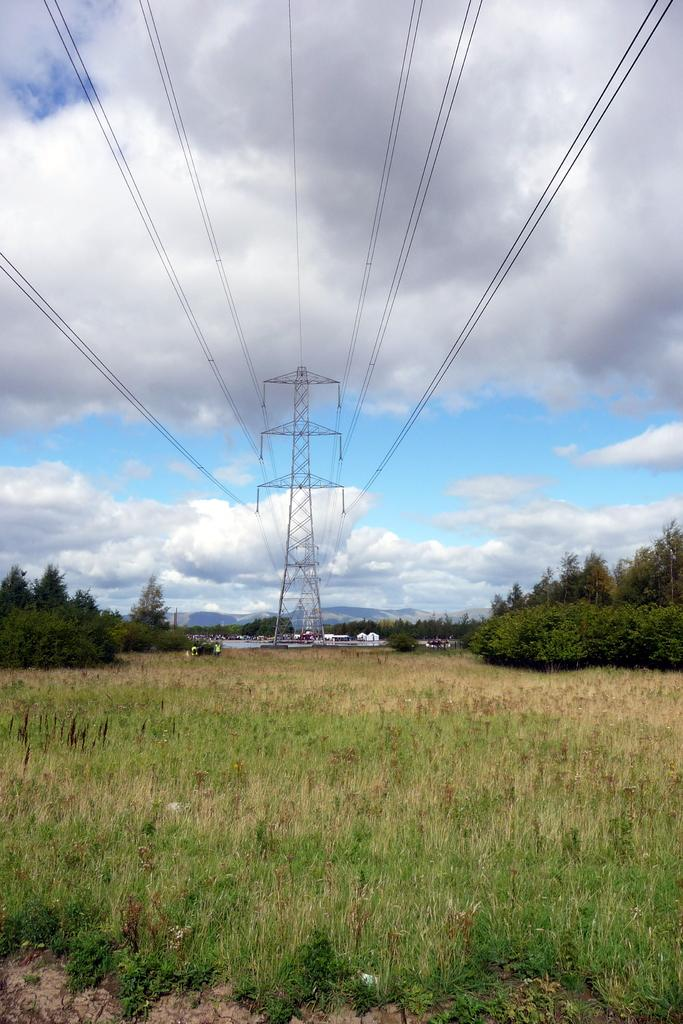What type of terrain is depicted in the image? There is a land filled with grass in the image. What structure can be seen in the image? There is a signal tower in the image. How is the signal tower connected to other structures? Many wires are attached to the signal tower. What type of vegetation is present in the image? There are trees around the ground in the image. How many houses can be seen in the image? There are no houses present in the image. What type of health services are available in the image? There is no indication of health services in the image. 